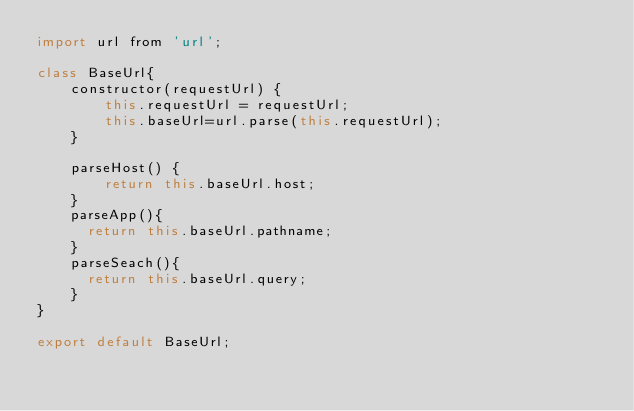<code> <loc_0><loc_0><loc_500><loc_500><_JavaScript_>import url from 'url';

class BaseUrl{
    constructor(requestUrl) {
        this.requestUrl = requestUrl;
        this.baseUrl=url.parse(this.requestUrl);
    }

    parseHost() {
        return this.baseUrl.host;
    }
    parseApp(){
      return this.baseUrl.pathname;
    }
    parseSeach(){
      return this.baseUrl.query;
    }
}

export default BaseUrl;
</code> 